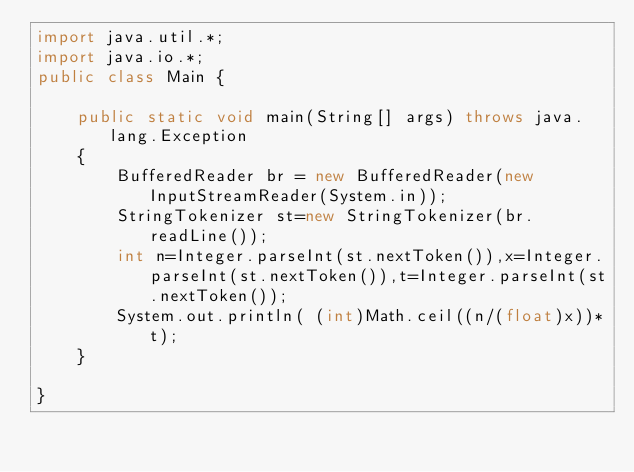Convert code to text. <code><loc_0><loc_0><loc_500><loc_500><_Java_>import java.util.*;
import java.io.*;
public class Main {

	public static void main(String[] args) throws java.lang.Exception
    {		
		BufferedReader br = new BufferedReader(new InputStreamReader(System.in));
		StringTokenizer st=new StringTokenizer(br.readLine());
		int n=Integer.parseInt(st.nextToken()),x=Integer.parseInt(st.nextToken()),t=Integer.parseInt(st.nextToken());
		System.out.println( (int)Math.ceil((n/(float)x))*t);
	}

}</code> 